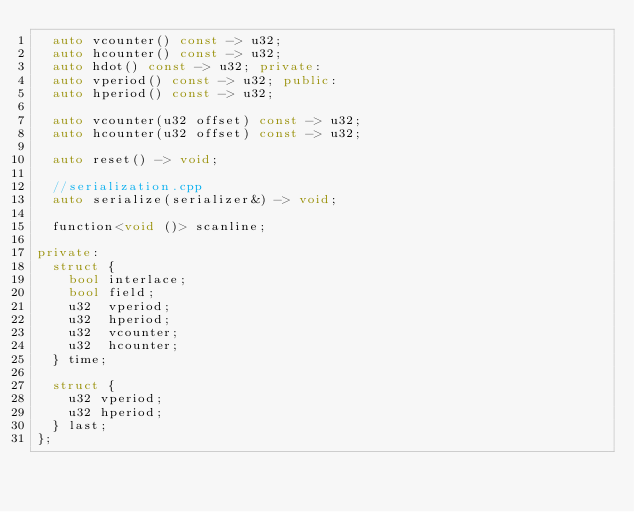<code> <loc_0><loc_0><loc_500><loc_500><_C++_>  auto vcounter() const -> u32;
  auto hcounter() const -> u32;
  auto hdot() const -> u32; private:
  auto vperiod() const -> u32; public:
  auto hperiod() const -> u32;

  auto vcounter(u32 offset) const -> u32;
  auto hcounter(u32 offset) const -> u32;

  auto reset() -> void;

  //serialization.cpp
  auto serialize(serializer&) -> void;

  function<void ()> scanline;

private:
  struct {
    bool interlace;
    bool field;
    u32  vperiod;
    u32  hperiod;
    u32  vcounter;
    u32  hcounter;
  } time;

  struct {
    u32 vperiod;
    u32 hperiod;
  } last;
};
</code> 